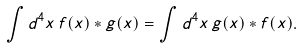Convert formula to latex. <formula><loc_0><loc_0><loc_500><loc_500>\int d ^ { 4 } x \, f ( x ) \ast g ( x ) = \int d ^ { 4 } x \, g ( x ) \ast f ( x ) .</formula> 